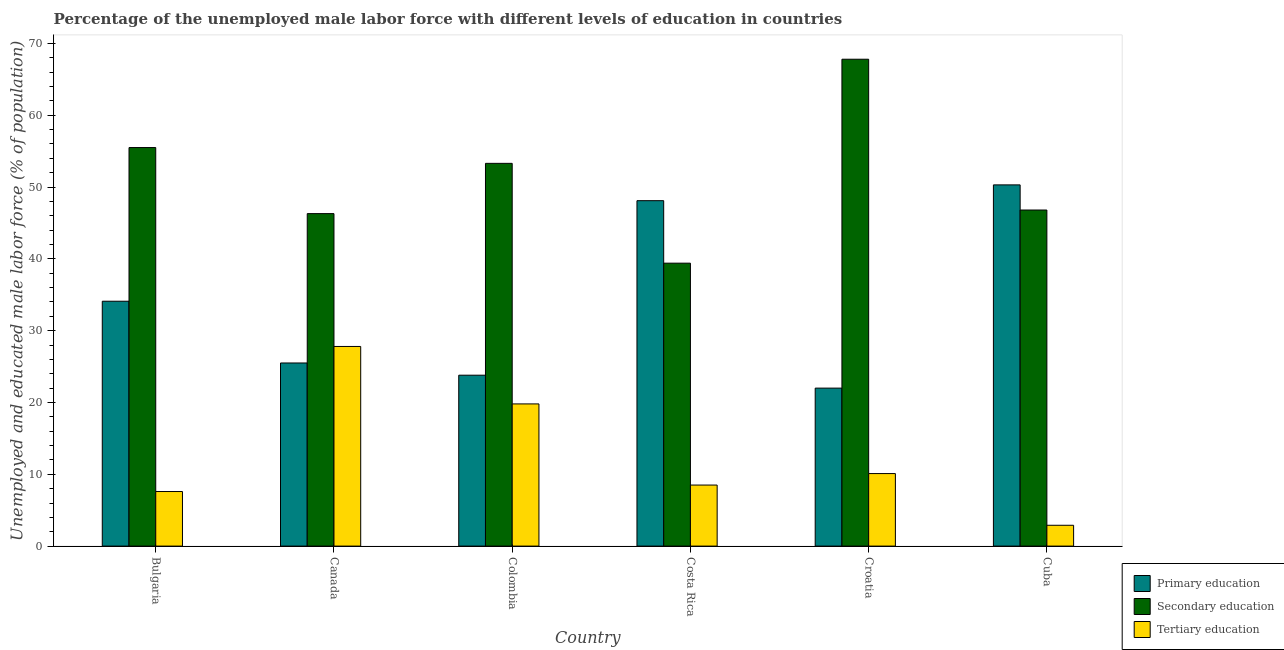How many different coloured bars are there?
Your answer should be compact. 3. How many groups of bars are there?
Make the answer very short. 6. How many bars are there on the 6th tick from the left?
Offer a very short reply. 3. How many bars are there on the 5th tick from the right?
Ensure brevity in your answer.  3. What is the label of the 4th group of bars from the left?
Keep it short and to the point. Costa Rica. In how many cases, is the number of bars for a given country not equal to the number of legend labels?
Keep it short and to the point. 0. What is the percentage of male labor force who received secondary education in Colombia?
Give a very brief answer. 53.3. Across all countries, what is the maximum percentage of male labor force who received secondary education?
Ensure brevity in your answer.  67.8. Across all countries, what is the minimum percentage of male labor force who received tertiary education?
Provide a short and direct response. 2.9. In which country was the percentage of male labor force who received secondary education maximum?
Make the answer very short. Croatia. What is the total percentage of male labor force who received primary education in the graph?
Give a very brief answer. 203.8. What is the difference between the percentage of male labor force who received primary education in Bulgaria and that in Cuba?
Ensure brevity in your answer.  -16.2. What is the difference between the percentage of male labor force who received primary education in Bulgaria and the percentage of male labor force who received secondary education in Colombia?
Your response must be concise. -19.2. What is the average percentage of male labor force who received tertiary education per country?
Offer a very short reply. 12.78. What is the difference between the percentage of male labor force who received tertiary education and percentage of male labor force who received secondary education in Croatia?
Provide a succinct answer. -57.7. What is the ratio of the percentage of male labor force who received secondary education in Colombia to that in Costa Rica?
Your response must be concise. 1.35. What is the difference between the highest and the lowest percentage of male labor force who received secondary education?
Give a very brief answer. 28.4. What does the 3rd bar from the left in Canada represents?
Ensure brevity in your answer.  Tertiary education. What does the 2nd bar from the right in Cuba represents?
Your response must be concise. Secondary education. How many bars are there?
Give a very brief answer. 18. How many countries are there in the graph?
Provide a short and direct response. 6. Does the graph contain any zero values?
Your answer should be compact. No. Does the graph contain grids?
Provide a succinct answer. No. How many legend labels are there?
Offer a terse response. 3. How are the legend labels stacked?
Offer a terse response. Vertical. What is the title of the graph?
Provide a short and direct response. Percentage of the unemployed male labor force with different levels of education in countries. Does "Secondary education" appear as one of the legend labels in the graph?
Give a very brief answer. Yes. What is the label or title of the Y-axis?
Offer a very short reply. Unemployed and educated male labor force (% of population). What is the Unemployed and educated male labor force (% of population) in Primary education in Bulgaria?
Provide a short and direct response. 34.1. What is the Unemployed and educated male labor force (% of population) of Secondary education in Bulgaria?
Your answer should be very brief. 55.5. What is the Unemployed and educated male labor force (% of population) in Tertiary education in Bulgaria?
Your answer should be very brief. 7.6. What is the Unemployed and educated male labor force (% of population) in Secondary education in Canada?
Provide a short and direct response. 46.3. What is the Unemployed and educated male labor force (% of population) in Tertiary education in Canada?
Keep it short and to the point. 27.8. What is the Unemployed and educated male labor force (% of population) in Primary education in Colombia?
Keep it short and to the point. 23.8. What is the Unemployed and educated male labor force (% of population) of Secondary education in Colombia?
Offer a very short reply. 53.3. What is the Unemployed and educated male labor force (% of population) of Tertiary education in Colombia?
Provide a short and direct response. 19.8. What is the Unemployed and educated male labor force (% of population) of Primary education in Costa Rica?
Provide a succinct answer. 48.1. What is the Unemployed and educated male labor force (% of population) of Secondary education in Costa Rica?
Make the answer very short. 39.4. What is the Unemployed and educated male labor force (% of population) in Primary education in Croatia?
Provide a short and direct response. 22. What is the Unemployed and educated male labor force (% of population) of Secondary education in Croatia?
Keep it short and to the point. 67.8. What is the Unemployed and educated male labor force (% of population) of Tertiary education in Croatia?
Provide a succinct answer. 10.1. What is the Unemployed and educated male labor force (% of population) in Primary education in Cuba?
Ensure brevity in your answer.  50.3. What is the Unemployed and educated male labor force (% of population) in Secondary education in Cuba?
Make the answer very short. 46.8. What is the Unemployed and educated male labor force (% of population) of Tertiary education in Cuba?
Give a very brief answer. 2.9. Across all countries, what is the maximum Unemployed and educated male labor force (% of population) of Primary education?
Make the answer very short. 50.3. Across all countries, what is the maximum Unemployed and educated male labor force (% of population) in Secondary education?
Ensure brevity in your answer.  67.8. Across all countries, what is the maximum Unemployed and educated male labor force (% of population) of Tertiary education?
Your answer should be compact. 27.8. Across all countries, what is the minimum Unemployed and educated male labor force (% of population) of Primary education?
Provide a succinct answer. 22. Across all countries, what is the minimum Unemployed and educated male labor force (% of population) in Secondary education?
Your answer should be very brief. 39.4. Across all countries, what is the minimum Unemployed and educated male labor force (% of population) in Tertiary education?
Provide a short and direct response. 2.9. What is the total Unemployed and educated male labor force (% of population) of Primary education in the graph?
Give a very brief answer. 203.8. What is the total Unemployed and educated male labor force (% of population) in Secondary education in the graph?
Offer a terse response. 309.1. What is the total Unemployed and educated male labor force (% of population) of Tertiary education in the graph?
Provide a short and direct response. 76.7. What is the difference between the Unemployed and educated male labor force (% of population) of Secondary education in Bulgaria and that in Canada?
Offer a very short reply. 9.2. What is the difference between the Unemployed and educated male labor force (% of population) of Tertiary education in Bulgaria and that in Canada?
Ensure brevity in your answer.  -20.2. What is the difference between the Unemployed and educated male labor force (% of population) in Secondary education in Bulgaria and that in Colombia?
Offer a terse response. 2.2. What is the difference between the Unemployed and educated male labor force (% of population) in Primary education in Bulgaria and that in Costa Rica?
Ensure brevity in your answer.  -14. What is the difference between the Unemployed and educated male labor force (% of population) in Secondary education in Bulgaria and that in Croatia?
Your response must be concise. -12.3. What is the difference between the Unemployed and educated male labor force (% of population) in Primary education in Bulgaria and that in Cuba?
Provide a short and direct response. -16.2. What is the difference between the Unemployed and educated male labor force (% of population) of Primary education in Canada and that in Costa Rica?
Ensure brevity in your answer.  -22.6. What is the difference between the Unemployed and educated male labor force (% of population) of Secondary education in Canada and that in Costa Rica?
Ensure brevity in your answer.  6.9. What is the difference between the Unemployed and educated male labor force (% of population) of Tertiary education in Canada and that in Costa Rica?
Offer a terse response. 19.3. What is the difference between the Unemployed and educated male labor force (% of population) in Secondary education in Canada and that in Croatia?
Ensure brevity in your answer.  -21.5. What is the difference between the Unemployed and educated male labor force (% of population) of Tertiary education in Canada and that in Croatia?
Your answer should be compact. 17.7. What is the difference between the Unemployed and educated male labor force (% of population) of Primary education in Canada and that in Cuba?
Offer a terse response. -24.8. What is the difference between the Unemployed and educated male labor force (% of population) of Tertiary education in Canada and that in Cuba?
Ensure brevity in your answer.  24.9. What is the difference between the Unemployed and educated male labor force (% of population) of Primary education in Colombia and that in Costa Rica?
Keep it short and to the point. -24.3. What is the difference between the Unemployed and educated male labor force (% of population) in Secondary education in Colombia and that in Costa Rica?
Give a very brief answer. 13.9. What is the difference between the Unemployed and educated male labor force (% of population) of Primary education in Colombia and that in Croatia?
Provide a succinct answer. 1.8. What is the difference between the Unemployed and educated male labor force (% of population) of Secondary education in Colombia and that in Croatia?
Offer a terse response. -14.5. What is the difference between the Unemployed and educated male labor force (% of population) in Primary education in Colombia and that in Cuba?
Offer a terse response. -26.5. What is the difference between the Unemployed and educated male labor force (% of population) in Secondary education in Colombia and that in Cuba?
Keep it short and to the point. 6.5. What is the difference between the Unemployed and educated male labor force (% of population) in Tertiary education in Colombia and that in Cuba?
Give a very brief answer. 16.9. What is the difference between the Unemployed and educated male labor force (% of population) of Primary education in Costa Rica and that in Croatia?
Your answer should be very brief. 26.1. What is the difference between the Unemployed and educated male labor force (% of population) of Secondary education in Costa Rica and that in Croatia?
Your answer should be very brief. -28.4. What is the difference between the Unemployed and educated male labor force (% of population) of Tertiary education in Costa Rica and that in Croatia?
Your answer should be compact. -1.6. What is the difference between the Unemployed and educated male labor force (% of population) in Primary education in Croatia and that in Cuba?
Your answer should be compact. -28.3. What is the difference between the Unemployed and educated male labor force (% of population) in Primary education in Bulgaria and the Unemployed and educated male labor force (% of population) in Tertiary education in Canada?
Your answer should be very brief. 6.3. What is the difference between the Unemployed and educated male labor force (% of population) of Secondary education in Bulgaria and the Unemployed and educated male labor force (% of population) of Tertiary education in Canada?
Offer a terse response. 27.7. What is the difference between the Unemployed and educated male labor force (% of population) in Primary education in Bulgaria and the Unemployed and educated male labor force (% of population) in Secondary education in Colombia?
Offer a terse response. -19.2. What is the difference between the Unemployed and educated male labor force (% of population) in Secondary education in Bulgaria and the Unemployed and educated male labor force (% of population) in Tertiary education in Colombia?
Your answer should be compact. 35.7. What is the difference between the Unemployed and educated male labor force (% of population) of Primary education in Bulgaria and the Unemployed and educated male labor force (% of population) of Secondary education in Costa Rica?
Offer a terse response. -5.3. What is the difference between the Unemployed and educated male labor force (% of population) of Primary education in Bulgaria and the Unemployed and educated male labor force (% of population) of Tertiary education in Costa Rica?
Offer a very short reply. 25.6. What is the difference between the Unemployed and educated male labor force (% of population) of Secondary education in Bulgaria and the Unemployed and educated male labor force (% of population) of Tertiary education in Costa Rica?
Your answer should be compact. 47. What is the difference between the Unemployed and educated male labor force (% of population) of Primary education in Bulgaria and the Unemployed and educated male labor force (% of population) of Secondary education in Croatia?
Give a very brief answer. -33.7. What is the difference between the Unemployed and educated male labor force (% of population) of Secondary education in Bulgaria and the Unemployed and educated male labor force (% of population) of Tertiary education in Croatia?
Give a very brief answer. 45.4. What is the difference between the Unemployed and educated male labor force (% of population) in Primary education in Bulgaria and the Unemployed and educated male labor force (% of population) in Tertiary education in Cuba?
Keep it short and to the point. 31.2. What is the difference between the Unemployed and educated male labor force (% of population) in Secondary education in Bulgaria and the Unemployed and educated male labor force (% of population) in Tertiary education in Cuba?
Provide a short and direct response. 52.6. What is the difference between the Unemployed and educated male labor force (% of population) of Primary education in Canada and the Unemployed and educated male labor force (% of population) of Secondary education in Colombia?
Offer a very short reply. -27.8. What is the difference between the Unemployed and educated male labor force (% of population) of Primary education in Canada and the Unemployed and educated male labor force (% of population) of Tertiary education in Colombia?
Provide a succinct answer. 5.7. What is the difference between the Unemployed and educated male labor force (% of population) in Primary education in Canada and the Unemployed and educated male labor force (% of population) in Tertiary education in Costa Rica?
Provide a succinct answer. 17. What is the difference between the Unemployed and educated male labor force (% of population) of Secondary education in Canada and the Unemployed and educated male labor force (% of population) of Tertiary education in Costa Rica?
Provide a succinct answer. 37.8. What is the difference between the Unemployed and educated male labor force (% of population) in Primary education in Canada and the Unemployed and educated male labor force (% of population) in Secondary education in Croatia?
Keep it short and to the point. -42.3. What is the difference between the Unemployed and educated male labor force (% of population) in Primary education in Canada and the Unemployed and educated male labor force (% of population) in Tertiary education in Croatia?
Offer a terse response. 15.4. What is the difference between the Unemployed and educated male labor force (% of population) in Secondary education in Canada and the Unemployed and educated male labor force (% of population) in Tertiary education in Croatia?
Your answer should be compact. 36.2. What is the difference between the Unemployed and educated male labor force (% of population) in Primary education in Canada and the Unemployed and educated male labor force (% of population) in Secondary education in Cuba?
Offer a very short reply. -21.3. What is the difference between the Unemployed and educated male labor force (% of population) of Primary education in Canada and the Unemployed and educated male labor force (% of population) of Tertiary education in Cuba?
Your response must be concise. 22.6. What is the difference between the Unemployed and educated male labor force (% of population) in Secondary education in Canada and the Unemployed and educated male labor force (% of population) in Tertiary education in Cuba?
Keep it short and to the point. 43.4. What is the difference between the Unemployed and educated male labor force (% of population) in Primary education in Colombia and the Unemployed and educated male labor force (% of population) in Secondary education in Costa Rica?
Keep it short and to the point. -15.6. What is the difference between the Unemployed and educated male labor force (% of population) of Secondary education in Colombia and the Unemployed and educated male labor force (% of population) of Tertiary education in Costa Rica?
Ensure brevity in your answer.  44.8. What is the difference between the Unemployed and educated male labor force (% of population) in Primary education in Colombia and the Unemployed and educated male labor force (% of population) in Secondary education in Croatia?
Keep it short and to the point. -44. What is the difference between the Unemployed and educated male labor force (% of population) of Primary education in Colombia and the Unemployed and educated male labor force (% of population) of Tertiary education in Croatia?
Offer a terse response. 13.7. What is the difference between the Unemployed and educated male labor force (% of population) of Secondary education in Colombia and the Unemployed and educated male labor force (% of population) of Tertiary education in Croatia?
Your response must be concise. 43.2. What is the difference between the Unemployed and educated male labor force (% of population) in Primary education in Colombia and the Unemployed and educated male labor force (% of population) in Secondary education in Cuba?
Offer a very short reply. -23. What is the difference between the Unemployed and educated male labor force (% of population) of Primary education in Colombia and the Unemployed and educated male labor force (% of population) of Tertiary education in Cuba?
Ensure brevity in your answer.  20.9. What is the difference between the Unemployed and educated male labor force (% of population) of Secondary education in Colombia and the Unemployed and educated male labor force (% of population) of Tertiary education in Cuba?
Give a very brief answer. 50.4. What is the difference between the Unemployed and educated male labor force (% of population) of Primary education in Costa Rica and the Unemployed and educated male labor force (% of population) of Secondary education in Croatia?
Offer a terse response. -19.7. What is the difference between the Unemployed and educated male labor force (% of population) in Secondary education in Costa Rica and the Unemployed and educated male labor force (% of population) in Tertiary education in Croatia?
Offer a very short reply. 29.3. What is the difference between the Unemployed and educated male labor force (% of population) in Primary education in Costa Rica and the Unemployed and educated male labor force (% of population) in Tertiary education in Cuba?
Ensure brevity in your answer.  45.2. What is the difference between the Unemployed and educated male labor force (% of population) of Secondary education in Costa Rica and the Unemployed and educated male labor force (% of population) of Tertiary education in Cuba?
Your answer should be compact. 36.5. What is the difference between the Unemployed and educated male labor force (% of population) of Primary education in Croatia and the Unemployed and educated male labor force (% of population) of Secondary education in Cuba?
Ensure brevity in your answer.  -24.8. What is the difference between the Unemployed and educated male labor force (% of population) in Secondary education in Croatia and the Unemployed and educated male labor force (% of population) in Tertiary education in Cuba?
Your answer should be compact. 64.9. What is the average Unemployed and educated male labor force (% of population) of Primary education per country?
Give a very brief answer. 33.97. What is the average Unemployed and educated male labor force (% of population) in Secondary education per country?
Offer a very short reply. 51.52. What is the average Unemployed and educated male labor force (% of population) of Tertiary education per country?
Give a very brief answer. 12.78. What is the difference between the Unemployed and educated male labor force (% of population) in Primary education and Unemployed and educated male labor force (% of population) in Secondary education in Bulgaria?
Your answer should be very brief. -21.4. What is the difference between the Unemployed and educated male labor force (% of population) in Primary education and Unemployed and educated male labor force (% of population) in Tertiary education in Bulgaria?
Give a very brief answer. 26.5. What is the difference between the Unemployed and educated male labor force (% of population) of Secondary education and Unemployed and educated male labor force (% of population) of Tertiary education in Bulgaria?
Offer a very short reply. 47.9. What is the difference between the Unemployed and educated male labor force (% of population) of Primary education and Unemployed and educated male labor force (% of population) of Secondary education in Canada?
Ensure brevity in your answer.  -20.8. What is the difference between the Unemployed and educated male labor force (% of population) of Primary education and Unemployed and educated male labor force (% of population) of Secondary education in Colombia?
Give a very brief answer. -29.5. What is the difference between the Unemployed and educated male labor force (% of population) in Primary education and Unemployed and educated male labor force (% of population) in Tertiary education in Colombia?
Provide a short and direct response. 4. What is the difference between the Unemployed and educated male labor force (% of population) in Secondary education and Unemployed and educated male labor force (% of population) in Tertiary education in Colombia?
Your answer should be very brief. 33.5. What is the difference between the Unemployed and educated male labor force (% of population) of Primary education and Unemployed and educated male labor force (% of population) of Secondary education in Costa Rica?
Offer a very short reply. 8.7. What is the difference between the Unemployed and educated male labor force (% of population) in Primary education and Unemployed and educated male labor force (% of population) in Tertiary education in Costa Rica?
Offer a very short reply. 39.6. What is the difference between the Unemployed and educated male labor force (% of population) of Secondary education and Unemployed and educated male labor force (% of population) of Tertiary education in Costa Rica?
Make the answer very short. 30.9. What is the difference between the Unemployed and educated male labor force (% of population) of Primary education and Unemployed and educated male labor force (% of population) of Secondary education in Croatia?
Your answer should be compact. -45.8. What is the difference between the Unemployed and educated male labor force (% of population) in Primary education and Unemployed and educated male labor force (% of population) in Tertiary education in Croatia?
Your answer should be very brief. 11.9. What is the difference between the Unemployed and educated male labor force (% of population) of Secondary education and Unemployed and educated male labor force (% of population) of Tertiary education in Croatia?
Provide a succinct answer. 57.7. What is the difference between the Unemployed and educated male labor force (% of population) of Primary education and Unemployed and educated male labor force (% of population) of Tertiary education in Cuba?
Give a very brief answer. 47.4. What is the difference between the Unemployed and educated male labor force (% of population) of Secondary education and Unemployed and educated male labor force (% of population) of Tertiary education in Cuba?
Ensure brevity in your answer.  43.9. What is the ratio of the Unemployed and educated male labor force (% of population) in Primary education in Bulgaria to that in Canada?
Your response must be concise. 1.34. What is the ratio of the Unemployed and educated male labor force (% of population) in Secondary education in Bulgaria to that in Canada?
Your answer should be compact. 1.2. What is the ratio of the Unemployed and educated male labor force (% of population) of Tertiary education in Bulgaria to that in Canada?
Your answer should be compact. 0.27. What is the ratio of the Unemployed and educated male labor force (% of population) in Primary education in Bulgaria to that in Colombia?
Offer a very short reply. 1.43. What is the ratio of the Unemployed and educated male labor force (% of population) in Secondary education in Bulgaria to that in Colombia?
Provide a short and direct response. 1.04. What is the ratio of the Unemployed and educated male labor force (% of population) in Tertiary education in Bulgaria to that in Colombia?
Offer a very short reply. 0.38. What is the ratio of the Unemployed and educated male labor force (% of population) in Primary education in Bulgaria to that in Costa Rica?
Provide a succinct answer. 0.71. What is the ratio of the Unemployed and educated male labor force (% of population) in Secondary education in Bulgaria to that in Costa Rica?
Provide a short and direct response. 1.41. What is the ratio of the Unemployed and educated male labor force (% of population) in Tertiary education in Bulgaria to that in Costa Rica?
Ensure brevity in your answer.  0.89. What is the ratio of the Unemployed and educated male labor force (% of population) in Primary education in Bulgaria to that in Croatia?
Your answer should be very brief. 1.55. What is the ratio of the Unemployed and educated male labor force (% of population) of Secondary education in Bulgaria to that in Croatia?
Offer a very short reply. 0.82. What is the ratio of the Unemployed and educated male labor force (% of population) in Tertiary education in Bulgaria to that in Croatia?
Keep it short and to the point. 0.75. What is the ratio of the Unemployed and educated male labor force (% of population) in Primary education in Bulgaria to that in Cuba?
Ensure brevity in your answer.  0.68. What is the ratio of the Unemployed and educated male labor force (% of population) of Secondary education in Bulgaria to that in Cuba?
Provide a short and direct response. 1.19. What is the ratio of the Unemployed and educated male labor force (% of population) of Tertiary education in Bulgaria to that in Cuba?
Your answer should be very brief. 2.62. What is the ratio of the Unemployed and educated male labor force (% of population) of Primary education in Canada to that in Colombia?
Your answer should be very brief. 1.07. What is the ratio of the Unemployed and educated male labor force (% of population) in Secondary education in Canada to that in Colombia?
Your response must be concise. 0.87. What is the ratio of the Unemployed and educated male labor force (% of population) of Tertiary education in Canada to that in Colombia?
Ensure brevity in your answer.  1.4. What is the ratio of the Unemployed and educated male labor force (% of population) of Primary education in Canada to that in Costa Rica?
Provide a succinct answer. 0.53. What is the ratio of the Unemployed and educated male labor force (% of population) of Secondary education in Canada to that in Costa Rica?
Offer a terse response. 1.18. What is the ratio of the Unemployed and educated male labor force (% of population) of Tertiary education in Canada to that in Costa Rica?
Offer a terse response. 3.27. What is the ratio of the Unemployed and educated male labor force (% of population) in Primary education in Canada to that in Croatia?
Make the answer very short. 1.16. What is the ratio of the Unemployed and educated male labor force (% of population) of Secondary education in Canada to that in Croatia?
Provide a succinct answer. 0.68. What is the ratio of the Unemployed and educated male labor force (% of population) of Tertiary education in Canada to that in Croatia?
Give a very brief answer. 2.75. What is the ratio of the Unemployed and educated male labor force (% of population) of Primary education in Canada to that in Cuba?
Your response must be concise. 0.51. What is the ratio of the Unemployed and educated male labor force (% of population) in Secondary education in Canada to that in Cuba?
Your response must be concise. 0.99. What is the ratio of the Unemployed and educated male labor force (% of population) in Tertiary education in Canada to that in Cuba?
Offer a terse response. 9.59. What is the ratio of the Unemployed and educated male labor force (% of population) of Primary education in Colombia to that in Costa Rica?
Provide a short and direct response. 0.49. What is the ratio of the Unemployed and educated male labor force (% of population) of Secondary education in Colombia to that in Costa Rica?
Make the answer very short. 1.35. What is the ratio of the Unemployed and educated male labor force (% of population) of Tertiary education in Colombia to that in Costa Rica?
Your response must be concise. 2.33. What is the ratio of the Unemployed and educated male labor force (% of population) in Primary education in Colombia to that in Croatia?
Keep it short and to the point. 1.08. What is the ratio of the Unemployed and educated male labor force (% of population) in Secondary education in Colombia to that in Croatia?
Provide a short and direct response. 0.79. What is the ratio of the Unemployed and educated male labor force (% of population) in Tertiary education in Colombia to that in Croatia?
Provide a short and direct response. 1.96. What is the ratio of the Unemployed and educated male labor force (% of population) in Primary education in Colombia to that in Cuba?
Ensure brevity in your answer.  0.47. What is the ratio of the Unemployed and educated male labor force (% of population) in Secondary education in Colombia to that in Cuba?
Your response must be concise. 1.14. What is the ratio of the Unemployed and educated male labor force (% of population) of Tertiary education in Colombia to that in Cuba?
Offer a very short reply. 6.83. What is the ratio of the Unemployed and educated male labor force (% of population) of Primary education in Costa Rica to that in Croatia?
Your answer should be very brief. 2.19. What is the ratio of the Unemployed and educated male labor force (% of population) of Secondary education in Costa Rica to that in Croatia?
Make the answer very short. 0.58. What is the ratio of the Unemployed and educated male labor force (% of population) in Tertiary education in Costa Rica to that in Croatia?
Provide a short and direct response. 0.84. What is the ratio of the Unemployed and educated male labor force (% of population) of Primary education in Costa Rica to that in Cuba?
Give a very brief answer. 0.96. What is the ratio of the Unemployed and educated male labor force (% of population) in Secondary education in Costa Rica to that in Cuba?
Offer a terse response. 0.84. What is the ratio of the Unemployed and educated male labor force (% of population) of Tertiary education in Costa Rica to that in Cuba?
Provide a short and direct response. 2.93. What is the ratio of the Unemployed and educated male labor force (% of population) of Primary education in Croatia to that in Cuba?
Make the answer very short. 0.44. What is the ratio of the Unemployed and educated male labor force (% of population) in Secondary education in Croatia to that in Cuba?
Ensure brevity in your answer.  1.45. What is the ratio of the Unemployed and educated male labor force (% of population) in Tertiary education in Croatia to that in Cuba?
Your response must be concise. 3.48. What is the difference between the highest and the second highest Unemployed and educated male labor force (% of population) of Primary education?
Your response must be concise. 2.2. What is the difference between the highest and the lowest Unemployed and educated male labor force (% of population) in Primary education?
Give a very brief answer. 28.3. What is the difference between the highest and the lowest Unemployed and educated male labor force (% of population) of Secondary education?
Give a very brief answer. 28.4. What is the difference between the highest and the lowest Unemployed and educated male labor force (% of population) in Tertiary education?
Make the answer very short. 24.9. 